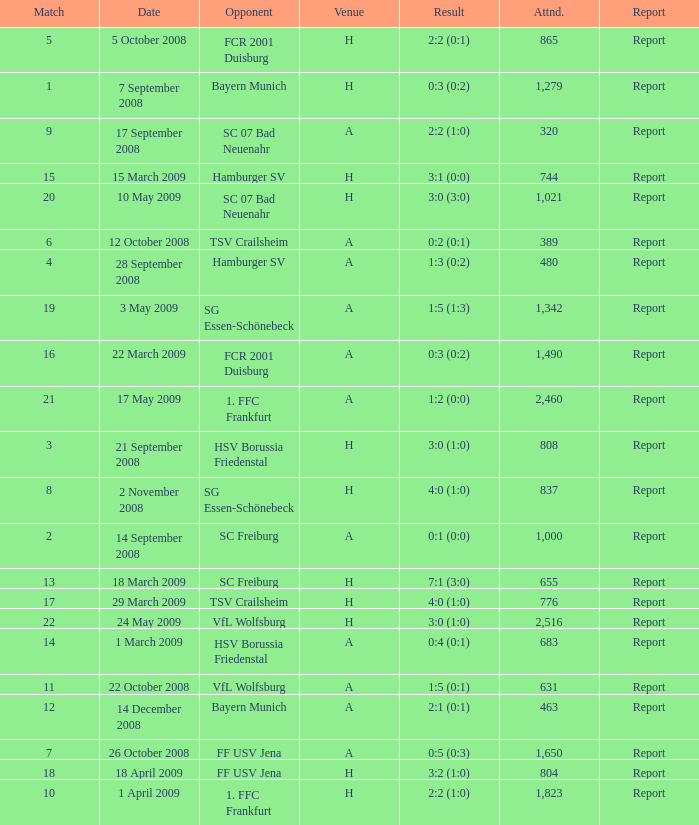Which match had more than 1,490 people in attendance to watch FCR 2001 Duisburg have a result of 0:3 (0:2)? None. 